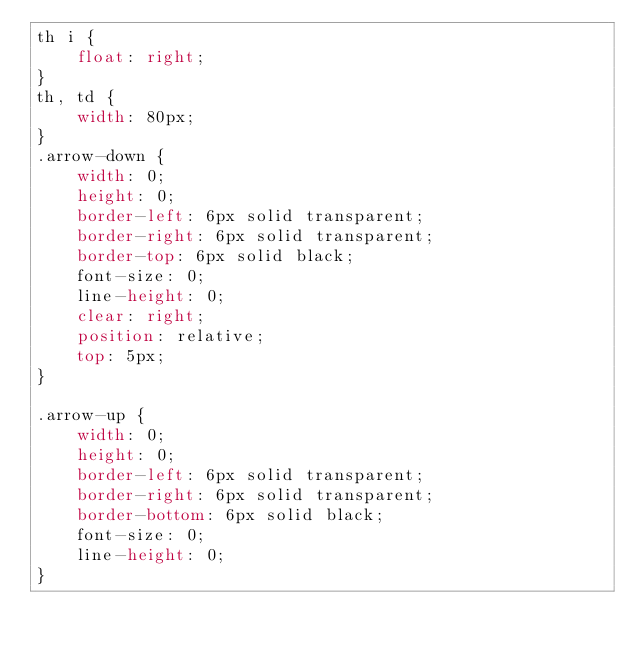<code> <loc_0><loc_0><loc_500><loc_500><_CSS_>th i {
	float: right;
}
th, td {
    width: 80px;
}
.arrow-down {
    width: 0;
    height: 0;
    border-left: 6px solid transparent;
    border-right: 6px solid transparent;
    border-top: 6px solid black;
    font-size: 0;
    line-height: 0;
    clear: right;
    position: relative;
    top: 5px;
}

.arrow-up {    
    width: 0;     
    height: 0;     
    border-left: 6px solid transparent;    
    border-right: 6px solid transparent; 
    border-bottom: 6px solid black;   
    font-size: 0;    
    line-height: 0;    
} 
</code> 